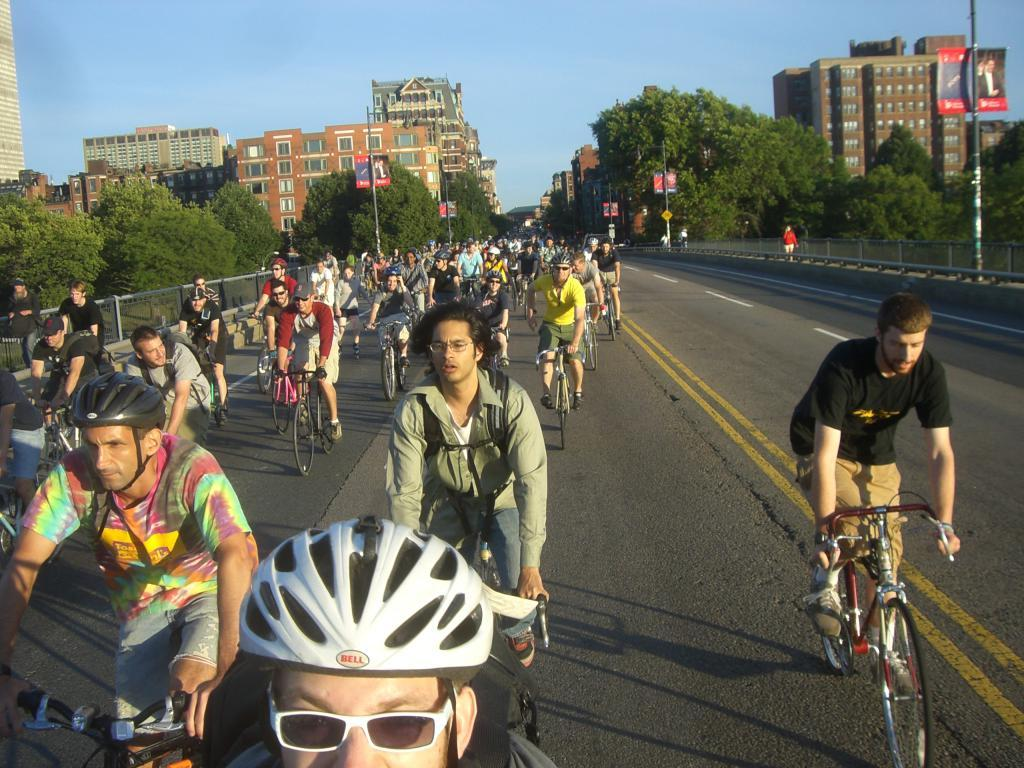What are the people in the image doing? The people in the image are riding bicycles. Where are the people riding their bicycles? They are riding bicycles on a road. What can be seen in the background of the image? There are buildings and trees visible in the background of the image. How many family members are present in the image? There is no information about family members in the image; it only shows people riding bicycles. What type of snakes can be seen slithering on the road in the image? There are no snakes present in the image; it only shows people riding bicycles on a road. 